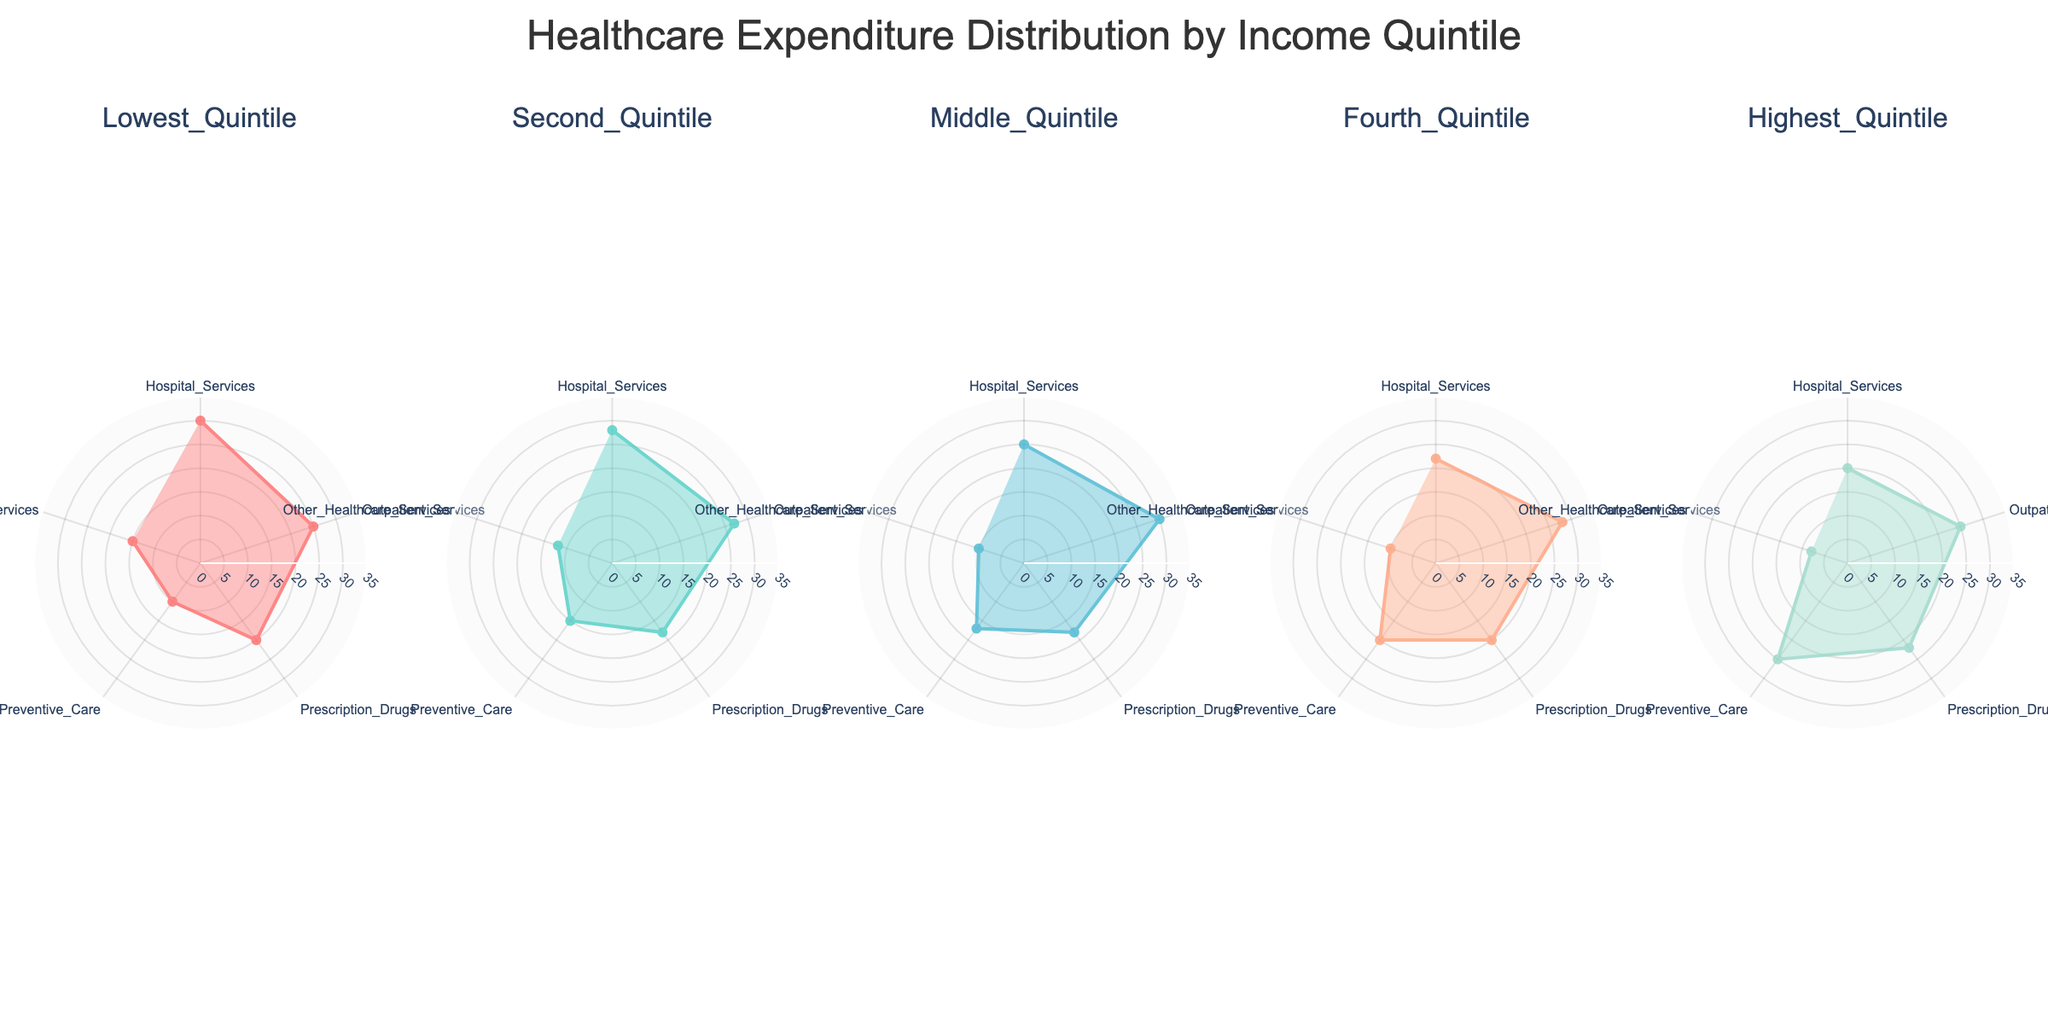What is the title of the figure? The title of the figure is displayed at the top and it reads "Healthcare Expenditure Distribution by Income Quintile".
Answer: Healthcare Expenditure Distribution by Income Quintile How many income quintiles are presented in the figure? There are five polar charts, each representing a different income quintile.
Answer: 5 Which healthcare category has the highest expenditure percentage for the Second Quintile? By examining the Second Quintile polar chart, the category with the highest expenditure percentage is "Outpatient Services" at 27%.
Answer: Outpatient Services What is the expenditure percentage for Prescription Drugs in the Lowest Quintile? In the Lowest Quintile polar chart, the expenditure percentage for Prescription Drugs is noted to be 20%.
Answer: 20% Which income quintile has the lowest expenditure percentage for Other Healthcare Services? By comparing the polar charts, the Highest Quintile has the lowest percentage for Other Healthcare Services at 8%.
Answer: Highest Quintile What is the total expenditure percentage for Hospital Services across all quintiles? Add the expenditure percentages for Hospital Services across all quintiles: 30 (Lowest) + 28 (Second) + 25 (Middle) + 22 (Fourth) + 20 (Highest) = 125%.
Answer: 125% Which quintile has the highest expenditure percentage on Preventive Care? By looking at the polar charts, the Highest Quintile has the highest expenditure percentage on Preventive Care at 25%.
Answer: Highest Quintile What is the average expenditure percentage for Preventive Care in the Fourth Quintile? The Fourth Quintile chart shows only one data point for Preventive Care at 20%. Therefore, the average is 20%.
Answer: 20% Which healthcare category shows the most consistent expenditure percentage across all quintiles? By examining all the charts, "Outpatient Services" shows relatively consistent percentages: 25 (Lowest), 27 (Second), 30 (Middle), 28 (Fourth), and 25 (Highest).
Answer: Outpatient Services Compare the expenditure percentages of Prescription Drugs between the Middle and Fourth Quintiles. Which one is higher and by how much? The Middle Quintile has a percentage of 18% for Prescription Drugs and the Fourth Quintile has 20%. The Fourth Quintile is higher by 2%.
Answer: Fourth Quintile, by 2% 